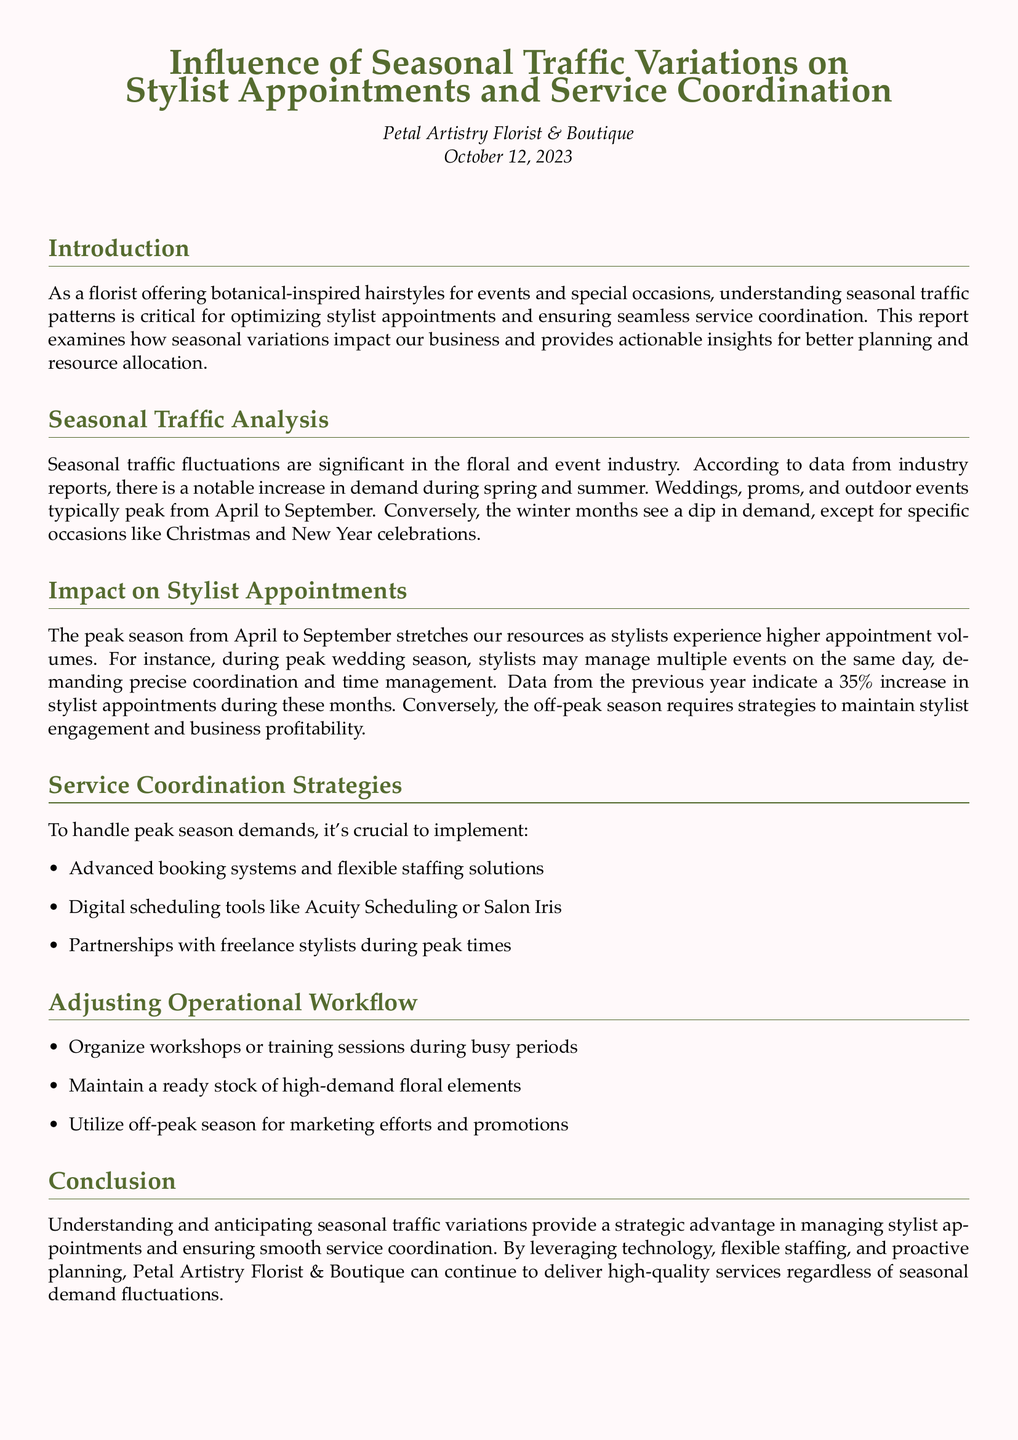What is the peak season for stylist appointments? The report indicates that the peak season for stylist appointments occurs from April to September when demand increases significantly.
Answer: April to September What percentage increase in stylist appointments is observed during peak wedding season? According to the document, there is a 35% increase in stylist appointments during the peak wedding season from the previous year.
Answer: 35% What is one suggested tool for digital scheduling? The report mentions using digital scheduling tools like Acuity Scheduling or Salon Iris to manage appointments effectively during peak times.
Answer: Acuity Scheduling What time of year sees a dip in demand, according to the report? The report suggests that the winter months generally experience a dip in demand for floral services, except during specific occasions.
Answer: Winter months What type of partnerships are recommended during peak times? The document recommends forming partnerships with freelance stylists to handle the increased demand during peak seasons.
Answer: Freelance stylists What is a strategy to maintain stylist engagement during off-peak season? Utilizing the off-peak season for marketing efforts and promotions is highlighted as a strategy to maintain stylist engagement and business profitability.
Answer: Marketing efforts What is the focus of the impact analysis section in the report? The impact analysis section focuses on how the peak season stretches resources and affects stylist appointment volumes, emphasizing the need for precise coordination.
Answer: Stylist appointment volumes What date was the report published? The document clearly states that the report was published on October 12, 2023.
Answer: October 12, 2023 